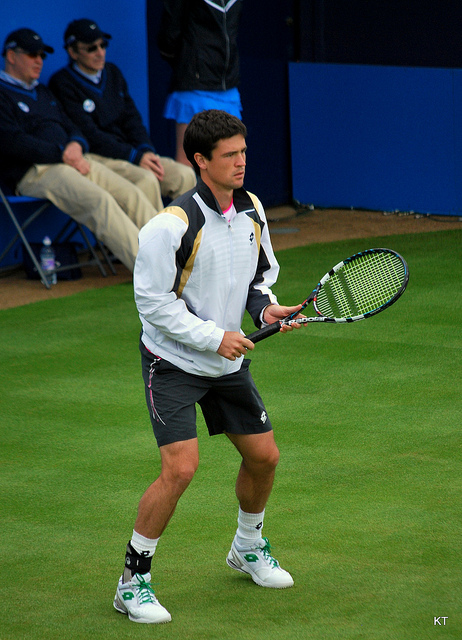Extract all visible text content from this image. KT 